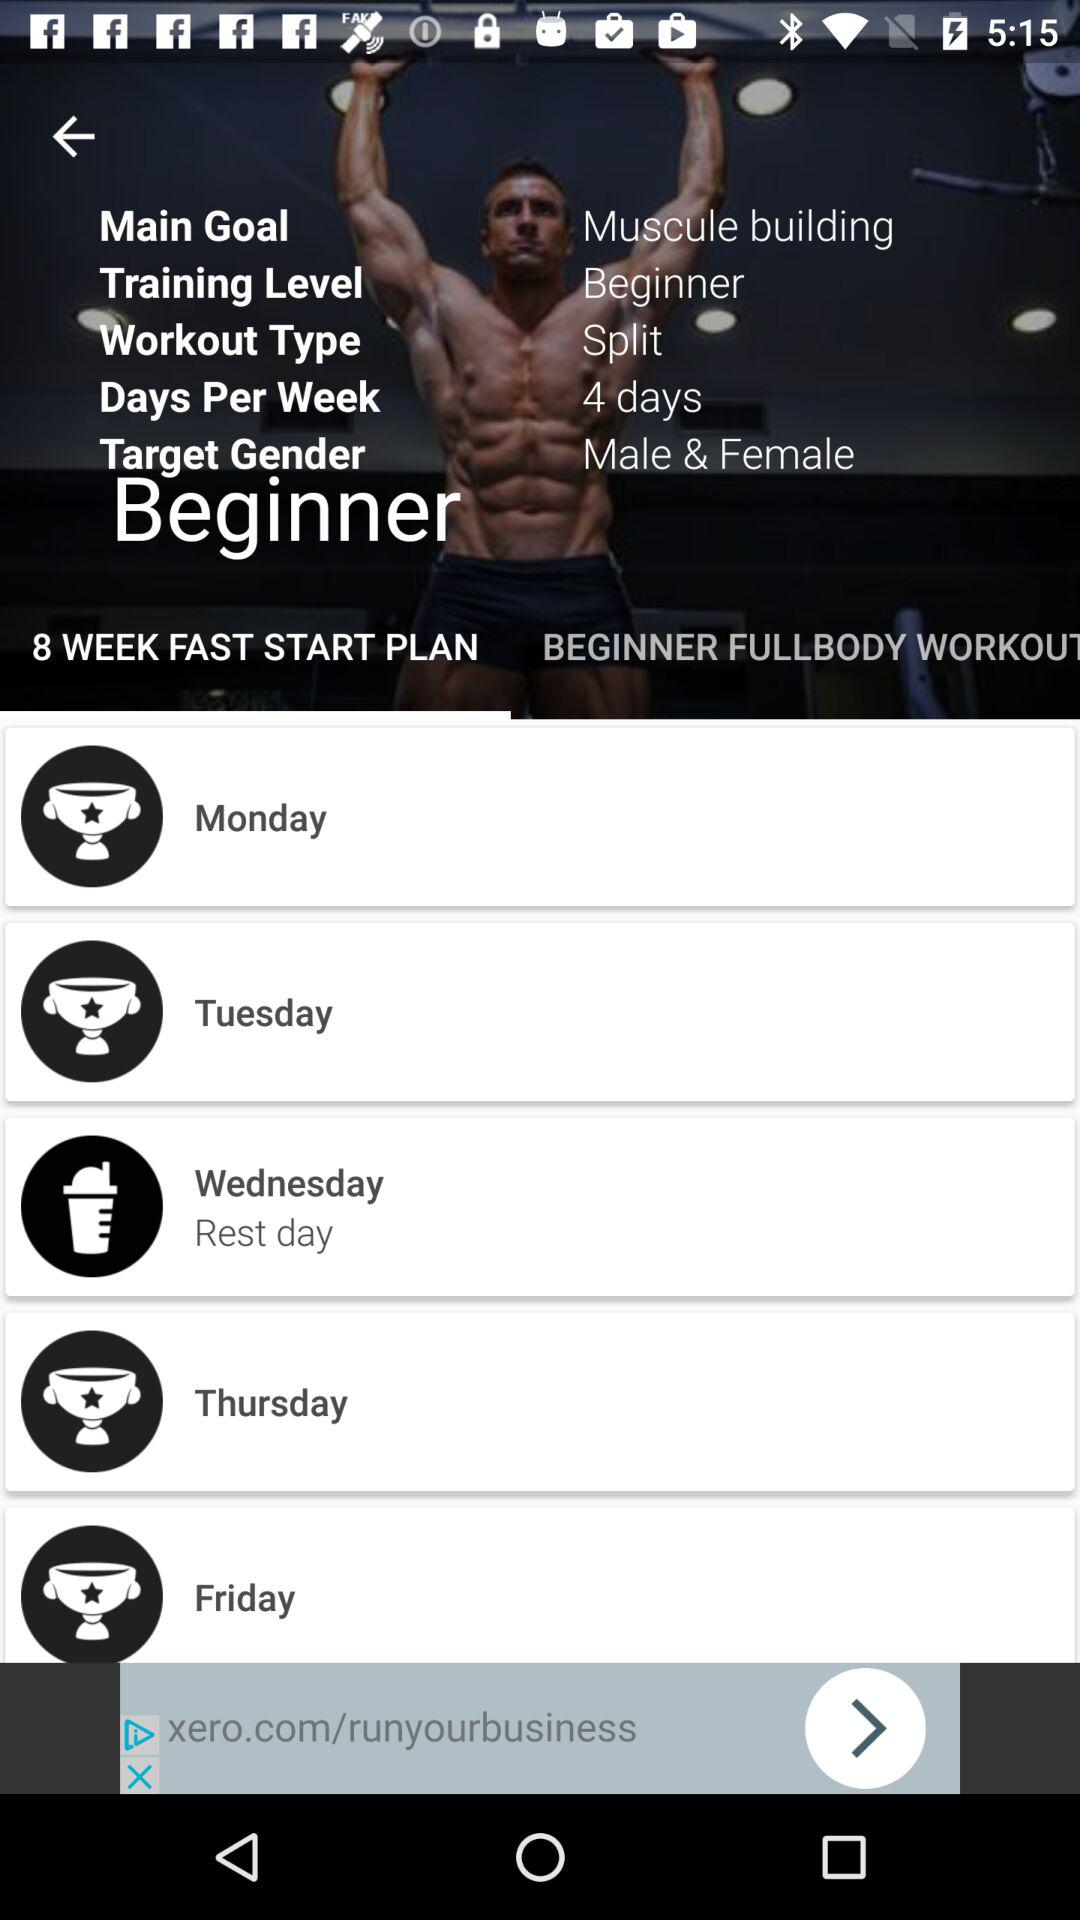How many days are there in the workout plan?
Answer the question using a single word or phrase. 4 